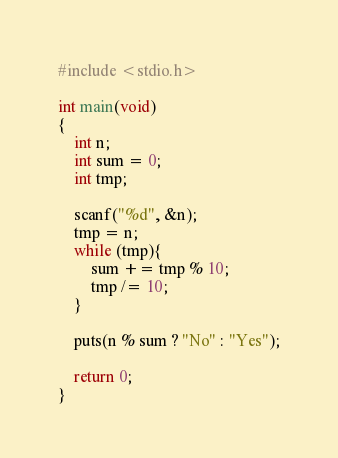<code> <loc_0><loc_0><loc_500><loc_500><_C_>#include <stdio.h>

int main(void)
{
    int n;
    int sum = 0;
    int tmp;

    scanf("%d", &n);
    tmp = n;
    while (tmp){
        sum += tmp % 10;
        tmp /= 10;
    }

    puts(n % sum ? "No" : "Yes");

    return 0;
}
</code> 